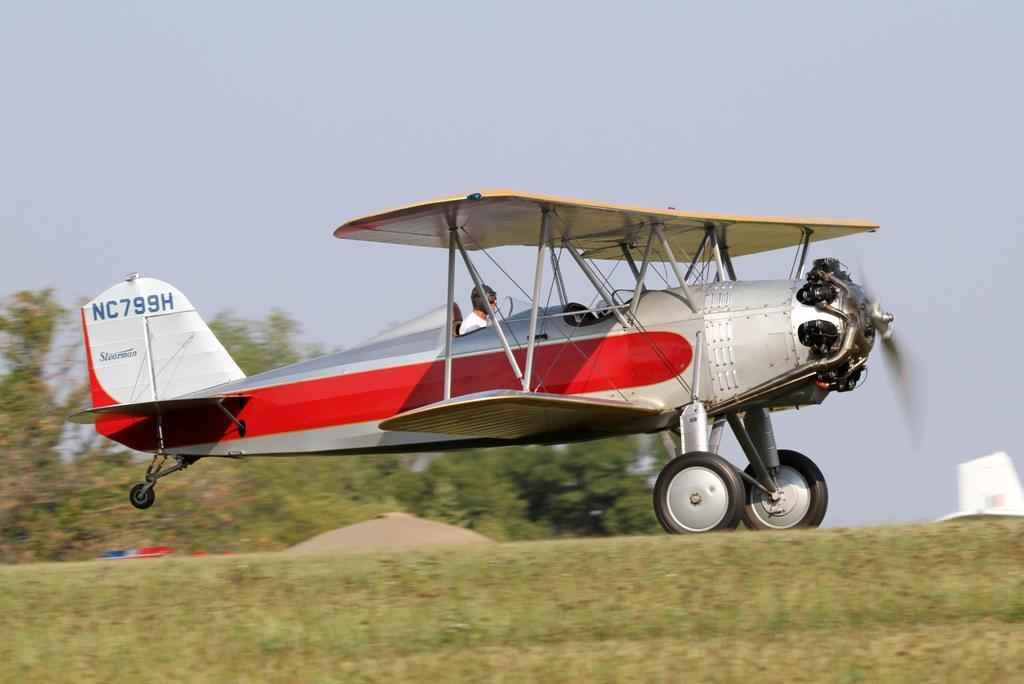Provide a one-sentence caption for the provided image. The NC799H Stearman air craft preparing for takeoff. 